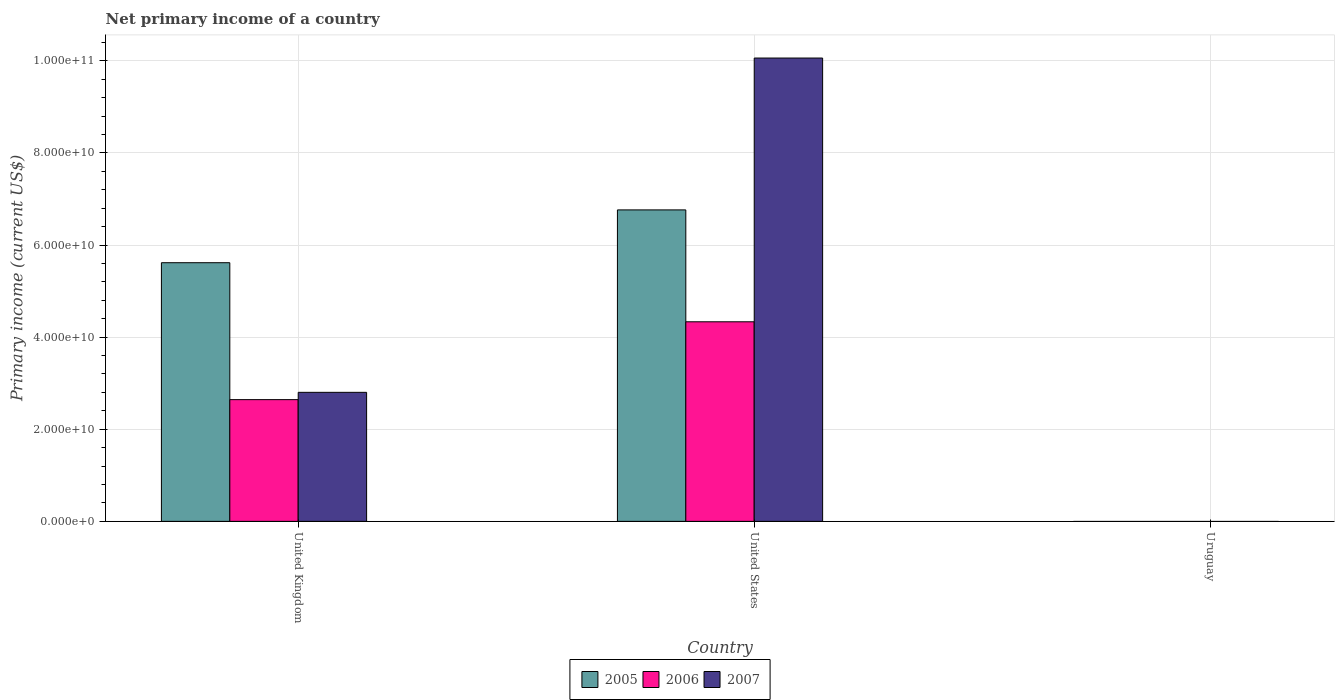Are the number of bars on each tick of the X-axis equal?
Keep it short and to the point. No. In how many cases, is the number of bars for a given country not equal to the number of legend labels?
Provide a short and direct response. 1. What is the primary income in 2005 in Uruguay?
Keep it short and to the point. 0. Across all countries, what is the maximum primary income in 2007?
Keep it short and to the point. 1.01e+11. In which country was the primary income in 2007 maximum?
Your answer should be very brief. United States. What is the total primary income in 2006 in the graph?
Your answer should be very brief. 6.98e+1. What is the difference between the primary income in 2006 in United Kingdom and that in United States?
Provide a short and direct response. -1.69e+1. What is the difference between the primary income in 2005 in United Kingdom and the primary income in 2006 in United States?
Keep it short and to the point. 1.28e+1. What is the average primary income in 2007 per country?
Provide a short and direct response. 4.29e+1. What is the difference between the primary income of/in 2006 and primary income of/in 2007 in United States?
Your response must be concise. -5.73e+1. What is the ratio of the primary income in 2007 in United Kingdom to that in United States?
Your response must be concise. 0.28. Is the difference between the primary income in 2006 in United Kingdom and United States greater than the difference between the primary income in 2007 in United Kingdom and United States?
Make the answer very short. Yes. What is the difference between the highest and the lowest primary income in 2005?
Your answer should be very brief. 6.76e+1. In how many countries, is the primary income in 2007 greater than the average primary income in 2007 taken over all countries?
Offer a very short reply. 1. Is it the case that in every country, the sum of the primary income in 2006 and primary income in 2005 is greater than the primary income in 2007?
Provide a short and direct response. No. What is the title of the graph?
Offer a very short reply. Net primary income of a country. Does "1990" appear as one of the legend labels in the graph?
Keep it short and to the point. No. What is the label or title of the Y-axis?
Your answer should be compact. Primary income (current US$). What is the Primary income (current US$) in 2005 in United Kingdom?
Offer a terse response. 5.62e+1. What is the Primary income (current US$) of 2006 in United Kingdom?
Give a very brief answer. 2.64e+1. What is the Primary income (current US$) in 2007 in United Kingdom?
Your response must be concise. 2.80e+1. What is the Primary income (current US$) of 2005 in United States?
Your response must be concise. 6.76e+1. What is the Primary income (current US$) in 2006 in United States?
Provide a succinct answer. 4.33e+1. What is the Primary income (current US$) of 2007 in United States?
Your answer should be compact. 1.01e+11. What is the Primary income (current US$) in 2005 in Uruguay?
Keep it short and to the point. 0. Across all countries, what is the maximum Primary income (current US$) of 2005?
Your answer should be compact. 6.76e+1. Across all countries, what is the maximum Primary income (current US$) of 2006?
Make the answer very short. 4.33e+1. Across all countries, what is the maximum Primary income (current US$) in 2007?
Your answer should be very brief. 1.01e+11. Across all countries, what is the minimum Primary income (current US$) of 2005?
Provide a short and direct response. 0. Across all countries, what is the minimum Primary income (current US$) of 2007?
Offer a terse response. 0. What is the total Primary income (current US$) of 2005 in the graph?
Offer a very short reply. 1.24e+11. What is the total Primary income (current US$) in 2006 in the graph?
Ensure brevity in your answer.  6.98e+1. What is the total Primary income (current US$) in 2007 in the graph?
Your response must be concise. 1.29e+11. What is the difference between the Primary income (current US$) in 2005 in United Kingdom and that in United States?
Ensure brevity in your answer.  -1.15e+1. What is the difference between the Primary income (current US$) in 2006 in United Kingdom and that in United States?
Offer a very short reply. -1.69e+1. What is the difference between the Primary income (current US$) of 2007 in United Kingdom and that in United States?
Give a very brief answer. -7.26e+1. What is the difference between the Primary income (current US$) of 2005 in United Kingdom and the Primary income (current US$) of 2006 in United States?
Ensure brevity in your answer.  1.28e+1. What is the difference between the Primary income (current US$) in 2005 in United Kingdom and the Primary income (current US$) in 2007 in United States?
Your answer should be very brief. -4.44e+1. What is the difference between the Primary income (current US$) in 2006 in United Kingdom and the Primary income (current US$) in 2007 in United States?
Your answer should be very brief. -7.42e+1. What is the average Primary income (current US$) of 2005 per country?
Provide a short and direct response. 4.13e+1. What is the average Primary income (current US$) of 2006 per country?
Offer a very short reply. 2.33e+1. What is the average Primary income (current US$) of 2007 per country?
Provide a short and direct response. 4.29e+1. What is the difference between the Primary income (current US$) of 2005 and Primary income (current US$) of 2006 in United Kingdom?
Offer a very short reply. 2.97e+1. What is the difference between the Primary income (current US$) in 2005 and Primary income (current US$) in 2007 in United Kingdom?
Provide a short and direct response. 2.81e+1. What is the difference between the Primary income (current US$) of 2006 and Primary income (current US$) of 2007 in United Kingdom?
Ensure brevity in your answer.  -1.58e+09. What is the difference between the Primary income (current US$) in 2005 and Primary income (current US$) in 2006 in United States?
Your answer should be very brief. 2.43e+1. What is the difference between the Primary income (current US$) in 2005 and Primary income (current US$) in 2007 in United States?
Make the answer very short. -3.30e+1. What is the difference between the Primary income (current US$) in 2006 and Primary income (current US$) in 2007 in United States?
Provide a short and direct response. -5.73e+1. What is the ratio of the Primary income (current US$) in 2005 in United Kingdom to that in United States?
Provide a succinct answer. 0.83. What is the ratio of the Primary income (current US$) in 2006 in United Kingdom to that in United States?
Give a very brief answer. 0.61. What is the ratio of the Primary income (current US$) in 2007 in United Kingdom to that in United States?
Make the answer very short. 0.28. What is the difference between the highest and the lowest Primary income (current US$) of 2005?
Provide a succinct answer. 6.76e+1. What is the difference between the highest and the lowest Primary income (current US$) of 2006?
Offer a very short reply. 4.33e+1. What is the difference between the highest and the lowest Primary income (current US$) of 2007?
Give a very brief answer. 1.01e+11. 